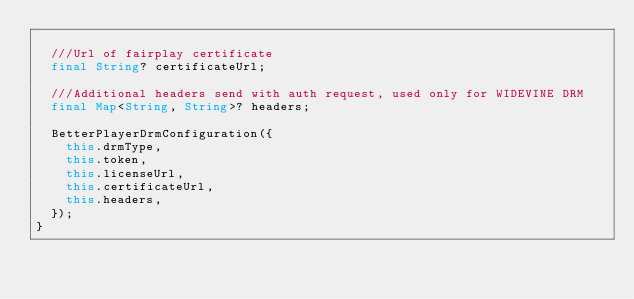Convert code to text. <code><loc_0><loc_0><loc_500><loc_500><_Dart_>
  ///Url of fairplay certificate
  final String? certificateUrl;

  ///Additional headers send with auth request, used only for WIDEVINE DRM
  final Map<String, String>? headers;

  BetterPlayerDrmConfiguration({
    this.drmType,
    this.token,
    this.licenseUrl,
    this.certificateUrl,
    this.headers,
  });
}
</code> 